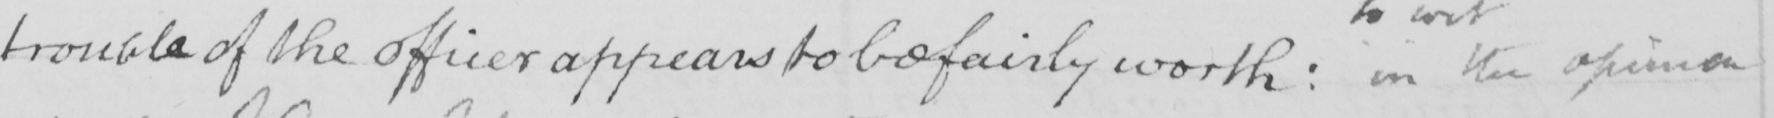Can you tell me what this handwritten text says? trouble of the officer appears to be fairly worth :  in the opinion 